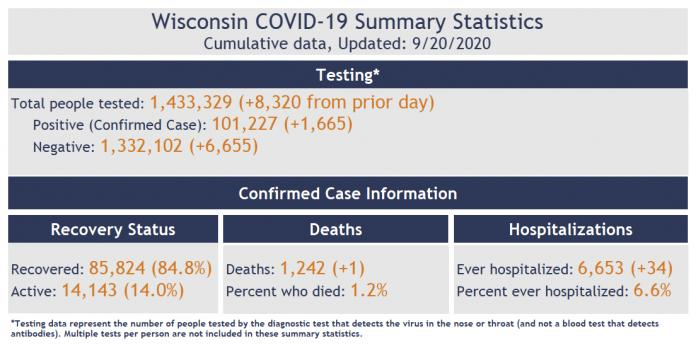Specify some key components in this picture. As of September 20, 2020, there were 14,143 active COVID-19 cases reported in the state of Wisconsin. As of September 20th, 2020, it was reported that 1.2% of the COVID-19 deaths in Wisconsin had been reported. As of September 20th, 2020, a total of 85,824 COVID-19 cases had been reported in the state of Wisconsin, and 85,824 cases had been recovered. As of September 20th, 2020, in Wisconsin, 6.6% of the confirmed COVID-19 cases were hospitalized. 